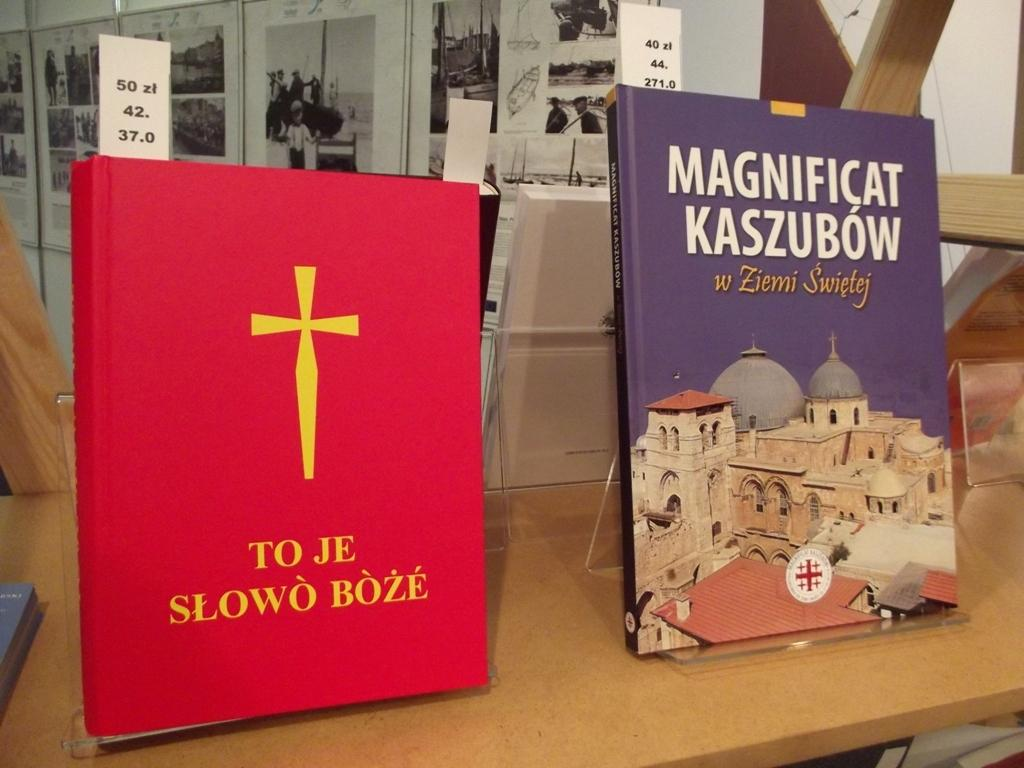<image>
Give a short and clear explanation of the subsequent image. Two books propped up on stands including TO JE SLOWO BOZE. 